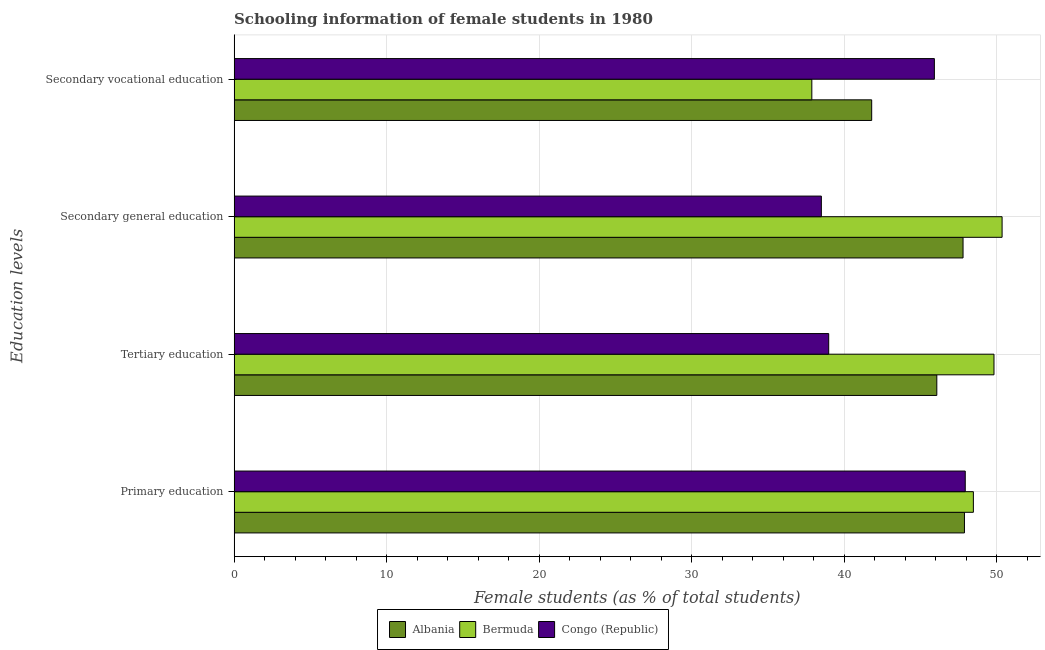How many different coloured bars are there?
Ensure brevity in your answer.  3. How many groups of bars are there?
Give a very brief answer. 4. How many bars are there on the 2nd tick from the top?
Keep it short and to the point. 3. What is the percentage of female students in secondary education in Congo (Republic)?
Your answer should be very brief. 38.51. Across all countries, what is the maximum percentage of female students in secondary vocational education?
Offer a terse response. 45.92. Across all countries, what is the minimum percentage of female students in primary education?
Give a very brief answer. 47.89. In which country was the percentage of female students in secondary vocational education maximum?
Ensure brevity in your answer.  Congo (Republic). In which country was the percentage of female students in secondary vocational education minimum?
Your response must be concise. Bermuda. What is the total percentage of female students in secondary education in the graph?
Your response must be concise. 136.68. What is the difference between the percentage of female students in primary education in Albania and that in Bermuda?
Give a very brief answer. -0.59. What is the difference between the percentage of female students in secondary education in Albania and the percentage of female students in secondary vocational education in Bermuda?
Offer a terse response. 9.92. What is the average percentage of female students in secondary education per country?
Offer a terse response. 45.56. What is the difference between the percentage of female students in tertiary education and percentage of female students in secondary vocational education in Congo (Republic)?
Make the answer very short. -6.93. What is the ratio of the percentage of female students in primary education in Bermuda to that in Congo (Republic)?
Give a very brief answer. 1.01. Is the percentage of female students in secondary vocational education in Congo (Republic) less than that in Albania?
Offer a very short reply. No. What is the difference between the highest and the second highest percentage of female students in primary education?
Make the answer very short. 0.53. What is the difference between the highest and the lowest percentage of female students in tertiary education?
Keep it short and to the point. 10.84. Is the sum of the percentage of female students in secondary vocational education in Bermuda and Albania greater than the maximum percentage of female students in primary education across all countries?
Make the answer very short. Yes. What does the 2nd bar from the top in Tertiary education represents?
Provide a short and direct response. Bermuda. What does the 3rd bar from the bottom in Primary education represents?
Offer a terse response. Congo (Republic). Is it the case that in every country, the sum of the percentage of female students in primary education and percentage of female students in tertiary education is greater than the percentage of female students in secondary education?
Keep it short and to the point. Yes. How many bars are there?
Provide a succinct answer. 12. Are all the bars in the graph horizontal?
Your response must be concise. Yes. Are the values on the major ticks of X-axis written in scientific E-notation?
Ensure brevity in your answer.  No. Does the graph contain grids?
Your answer should be very brief. Yes. How many legend labels are there?
Give a very brief answer. 3. What is the title of the graph?
Your response must be concise. Schooling information of female students in 1980. What is the label or title of the X-axis?
Your answer should be very brief. Female students (as % of total students). What is the label or title of the Y-axis?
Offer a terse response. Education levels. What is the Female students (as % of total students) in Albania in Primary education?
Make the answer very short. 47.89. What is the Female students (as % of total students) in Bermuda in Primary education?
Your answer should be compact. 48.48. What is the Female students (as % of total students) of Congo (Republic) in Primary education?
Give a very brief answer. 47.95. What is the Female students (as % of total students) in Albania in Tertiary education?
Ensure brevity in your answer.  46.08. What is the Female students (as % of total students) of Bermuda in Tertiary education?
Ensure brevity in your answer.  49.83. What is the Female students (as % of total students) of Congo (Republic) in Tertiary education?
Provide a short and direct response. 38.99. What is the Female students (as % of total students) of Albania in Secondary general education?
Offer a terse response. 47.8. What is the Female students (as % of total students) in Bermuda in Secondary general education?
Make the answer very short. 50.36. What is the Female students (as % of total students) of Congo (Republic) in Secondary general education?
Provide a succinct answer. 38.51. What is the Female students (as % of total students) in Albania in Secondary vocational education?
Make the answer very short. 41.81. What is the Female students (as % of total students) in Bermuda in Secondary vocational education?
Offer a terse response. 37.89. What is the Female students (as % of total students) in Congo (Republic) in Secondary vocational education?
Your answer should be very brief. 45.92. Across all Education levels, what is the maximum Female students (as % of total students) of Albania?
Offer a very short reply. 47.89. Across all Education levels, what is the maximum Female students (as % of total students) in Bermuda?
Your answer should be very brief. 50.36. Across all Education levels, what is the maximum Female students (as % of total students) in Congo (Republic)?
Provide a succinct answer. 47.95. Across all Education levels, what is the minimum Female students (as % of total students) of Albania?
Keep it short and to the point. 41.81. Across all Education levels, what is the minimum Female students (as % of total students) of Bermuda?
Your answer should be very brief. 37.89. Across all Education levels, what is the minimum Female students (as % of total students) of Congo (Republic)?
Your answer should be compact. 38.51. What is the total Female students (as % of total students) of Albania in the graph?
Your answer should be compact. 183.59. What is the total Female students (as % of total students) in Bermuda in the graph?
Make the answer very short. 186.56. What is the total Female students (as % of total students) of Congo (Republic) in the graph?
Give a very brief answer. 171.37. What is the difference between the Female students (as % of total students) of Albania in Primary education and that in Tertiary education?
Your response must be concise. 1.81. What is the difference between the Female students (as % of total students) of Bermuda in Primary education and that in Tertiary education?
Offer a terse response. -1.35. What is the difference between the Female students (as % of total students) of Congo (Republic) in Primary education and that in Tertiary education?
Your answer should be compact. 8.95. What is the difference between the Female students (as % of total students) in Albania in Primary education and that in Secondary general education?
Your answer should be compact. 0.09. What is the difference between the Female students (as % of total students) of Bermuda in Primary education and that in Secondary general education?
Offer a very short reply. -1.88. What is the difference between the Female students (as % of total students) of Congo (Republic) in Primary education and that in Secondary general education?
Give a very brief answer. 9.44. What is the difference between the Female students (as % of total students) in Albania in Primary education and that in Secondary vocational education?
Offer a terse response. 6.08. What is the difference between the Female students (as % of total students) in Bermuda in Primary education and that in Secondary vocational education?
Give a very brief answer. 10.59. What is the difference between the Female students (as % of total students) in Congo (Republic) in Primary education and that in Secondary vocational education?
Your answer should be compact. 2.02. What is the difference between the Female students (as % of total students) in Albania in Tertiary education and that in Secondary general education?
Provide a short and direct response. -1.72. What is the difference between the Female students (as % of total students) of Bermuda in Tertiary education and that in Secondary general education?
Give a very brief answer. -0.53. What is the difference between the Female students (as % of total students) in Congo (Republic) in Tertiary education and that in Secondary general education?
Offer a terse response. 0.48. What is the difference between the Female students (as % of total students) of Albania in Tertiary education and that in Secondary vocational education?
Provide a succinct answer. 4.27. What is the difference between the Female students (as % of total students) in Bermuda in Tertiary education and that in Secondary vocational education?
Provide a succinct answer. 11.95. What is the difference between the Female students (as % of total students) of Congo (Republic) in Tertiary education and that in Secondary vocational education?
Ensure brevity in your answer.  -6.93. What is the difference between the Female students (as % of total students) of Albania in Secondary general education and that in Secondary vocational education?
Ensure brevity in your answer.  5.99. What is the difference between the Female students (as % of total students) of Bermuda in Secondary general education and that in Secondary vocational education?
Your response must be concise. 12.48. What is the difference between the Female students (as % of total students) in Congo (Republic) in Secondary general education and that in Secondary vocational education?
Keep it short and to the point. -7.41. What is the difference between the Female students (as % of total students) of Albania in Primary education and the Female students (as % of total students) of Bermuda in Tertiary education?
Offer a terse response. -1.94. What is the difference between the Female students (as % of total students) in Albania in Primary education and the Female students (as % of total students) in Congo (Republic) in Tertiary education?
Make the answer very short. 8.9. What is the difference between the Female students (as % of total students) in Bermuda in Primary education and the Female students (as % of total students) in Congo (Republic) in Tertiary education?
Your answer should be very brief. 9.49. What is the difference between the Female students (as % of total students) in Albania in Primary education and the Female students (as % of total students) in Bermuda in Secondary general education?
Provide a succinct answer. -2.47. What is the difference between the Female students (as % of total students) in Albania in Primary education and the Female students (as % of total students) in Congo (Republic) in Secondary general education?
Keep it short and to the point. 9.38. What is the difference between the Female students (as % of total students) of Bermuda in Primary education and the Female students (as % of total students) of Congo (Republic) in Secondary general education?
Give a very brief answer. 9.97. What is the difference between the Female students (as % of total students) in Albania in Primary education and the Female students (as % of total students) in Bermuda in Secondary vocational education?
Your answer should be compact. 10.01. What is the difference between the Female students (as % of total students) in Albania in Primary education and the Female students (as % of total students) in Congo (Republic) in Secondary vocational education?
Your answer should be very brief. 1.97. What is the difference between the Female students (as % of total students) of Bermuda in Primary education and the Female students (as % of total students) of Congo (Republic) in Secondary vocational education?
Offer a very short reply. 2.56. What is the difference between the Female students (as % of total students) of Albania in Tertiary education and the Female students (as % of total students) of Bermuda in Secondary general education?
Your answer should be compact. -4.28. What is the difference between the Female students (as % of total students) of Albania in Tertiary education and the Female students (as % of total students) of Congo (Republic) in Secondary general education?
Provide a succinct answer. 7.57. What is the difference between the Female students (as % of total students) of Bermuda in Tertiary education and the Female students (as % of total students) of Congo (Republic) in Secondary general education?
Give a very brief answer. 11.32. What is the difference between the Female students (as % of total students) in Albania in Tertiary education and the Female students (as % of total students) in Bermuda in Secondary vocational education?
Provide a short and direct response. 8.2. What is the difference between the Female students (as % of total students) of Albania in Tertiary education and the Female students (as % of total students) of Congo (Republic) in Secondary vocational education?
Keep it short and to the point. 0.16. What is the difference between the Female students (as % of total students) of Bermuda in Tertiary education and the Female students (as % of total students) of Congo (Republic) in Secondary vocational education?
Your answer should be compact. 3.91. What is the difference between the Female students (as % of total students) of Albania in Secondary general education and the Female students (as % of total students) of Bermuda in Secondary vocational education?
Provide a short and direct response. 9.92. What is the difference between the Female students (as % of total students) of Albania in Secondary general education and the Female students (as % of total students) of Congo (Republic) in Secondary vocational education?
Provide a short and direct response. 1.88. What is the difference between the Female students (as % of total students) of Bermuda in Secondary general education and the Female students (as % of total students) of Congo (Republic) in Secondary vocational education?
Your answer should be very brief. 4.44. What is the average Female students (as % of total students) of Albania per Education levels?
Make the answer very short. 45.9. What is the average Female students (as % of total students) of Bermuda per Education levels?
Ensure brevity in your answer.  46.64. What is the average Female students (as % of total students) in Congo (Republic) per Education levels?
Keep it short and to the point. 42.84. What is the difference between the Female students (as % of total students) of Albania and Female students (as % of total students) of Bermuda in Primary education?
Make the answer very short. -0.59. What is the difference between the Female students (as % of total students) in Albania and Female students (as % of total students) in Congo (Republic) in Primary education?
Make the answer very short. -0.05. What is the difference between the Female students (as % of total students) of Bermuda and Female students (as % of total students) of Congo (Republic) in Primary education?
Provide a succinct answer. 0.53. What is the difference between the Female students (as % of total students) in Albania and Female students (as % of total students) in Bermuda in Tertiary education?
Your answer should be compact. -3.75. What is the difference between the Female students (as % of total students) of Albania and Female students (as % of total students) of Congo (Republic) in Tertiary education?
Offer a very short reply. 7.09. What is the difference between the Female students (as % of total students) of Bermuda and Female students (as % of total students) of Congo (Republic) in Tertiary education?
Your answer should be compact. 10.84. What is the difference between the Female students (as % of total students) in Albania and Female students (as % of total students) in Bermuda in Secondary general education?
Make the answer very short. -2.56. What is the difference between the Female students (as % of total students) in Albania and Female students (as % of total students) in Congo (Republic) in Secondary general education?
Keep it short and to the point. 9.29. What is the difference between the Female students (as % of total students) of Bermuda and Female students (as % of total students) of Congo (Republic) in Secondary general education?
Offer a terse response. 11.85. What is the difference between the Female students (as % of total students) in Albania and Female students (as % of total students) in Bermuda in Secondary vocational education?
Provide a succinct answer. 3.93. What is the difference between the Female students (as % of total students) of Albania and Female students (as % of total students) of Congo (Republic) in Secondary vocational education?
Keep it short and to the point. -4.11. What is the difference between the Female students (as % of total students) in Bermuda and Female students (as % of total students) in Congo (Republic) in Secondary vocational education?
Make the answer very short. -8.04. What is the ratio of the Female students (as % of total students) in Albania in Primary education to that in Tertiary education?
Provide a short and direct response. 1.04. What is the ratio of the Female students (as % of total students) of Bermuda in Primary education to that in Tertiary education?
Ensure brevity in your answer.  0.97. What is the ratio of the Female students (as % of total students) in Congo (Republic) in Primary education to that in Tertiary education?
Offer a terse response. 1.23. What is the ratio of the Female students (as % of total students) of Albania in Primary education to that in Secondary general education?
Ensure brevity in your answer.  1. What is the ratio of the Female students (as % of total students) of Bermuda in Primary education to that in Secondary general education?
Ensure brevity in your answer.  0.96. What is the ratio of the Female students (as % of total students) in Congo (Republic) in Primary education to that in Secondary general education?
Give a very brief answer. 1.25. What is the ratio of the Female students (as % of total students) of Albania in Primary education to that in Secondary vocational education?
Offer a very short reply. 1.15. What is the ratio of the Female students (as % of total students) of Bermuda in Primary education to that in Secondary vocational education?
Keep it short and to the point. 1.28. What is the ratio of the Female students (as % of total students) in Congo (Republic) in Primary education to that in Secondary vocational education?
Your answer should be very brief. 1.04. What is the ratio of the Female students (as % of total students) of Bermuda in Tertiary education to that in Secondary general education?
Your answer should be very brief. 0.99. What is the ratio of the Female students (as % of total students) in Congo (Republic) in Tertiary education to that in Secondary general education?
Keep it short and to the point. 1.01. What is the ratio of the Female students (as % of total students) of Albania in Tertiary education to that in Secondary vocational education?
Your answer should be compact. 1.1. What is the ratio of the Female students (as % of total students) in Bermuda in Tertiary education to that in Secondary vocational education?
Keep it short and to the point. 1.32. What is the ratio of the Female students (as % of total students) of Congo (Republic) in Tertiary education to that in Secondary vocational education?
Give a very brief answer. 0.85. What is the ratio of the Female students (as % of total students) of Albania in Secondary general education to that in Secondary vocational education?
Provide a short and direct response. 1.14. What is the ratio of the Female students (as % of total students) in Bermuda in Secondary general education to that in Secondary vocational education?
Ensure brevity in your answer.  1.33. What is the ratio of the Female students (as % of total students) in Congo (Republic) in Secondary general education to that in Secondary vocational education?
Offer a very short reply. 0.84. What is the difference between the highest and the second highest Female students (as % of total students) of Albania?
Keep it short and to the point. 0.09. What is the difference between the highest and the second highest Female students (as % of total students) of Bermuda?
Give a very brief answer. 0.53. What is the difference between the highest and the second highest Female students (as % of total students) in Congo (Republic)?
Provide a short and direct response. 2.02. What is the difference between the highest and the lowest Female students (as % of total students) of Albania?
Give a very brief answer. 6.08. What is the difference between the highest and the lowest Female students (as % of total students) in Bermuda?
Keep it short and to the point. 12.48. What is the difference between the highest and the lowest Female students (as % of total students) in Congo (Republic)?
Offer a very short reply. 9.44. 